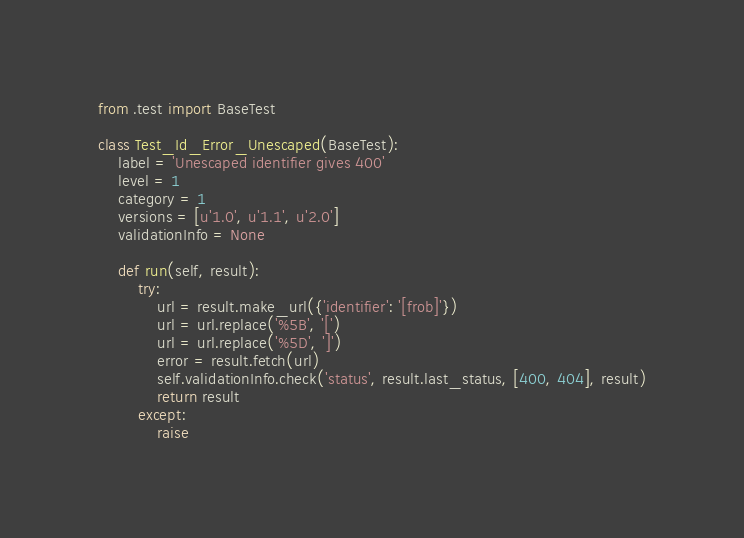<code> <loc_0><loc_0><loc_500><loc_500><_Python_>from .test import BaseTest

class Test_Id_Error_Unescaped(BaseTest):
    label = 'Unescaped identifier gives 400'
    level = 1
    category = 1
    versions = [u'1.0', u'1.1', u'2.0']
    validationInfo = None

    def run(self, result):
        try:
            url = result.make_url({'identifier': '[frob]'})
            url = url.replace('%5B', '[')
            url = url.replace('%5D', ']')
            error = result.fetch(url)
            self.validationInfo.check('status', result.last_status, [400, 404], result)
            return result   
        except:
            raise</code> 